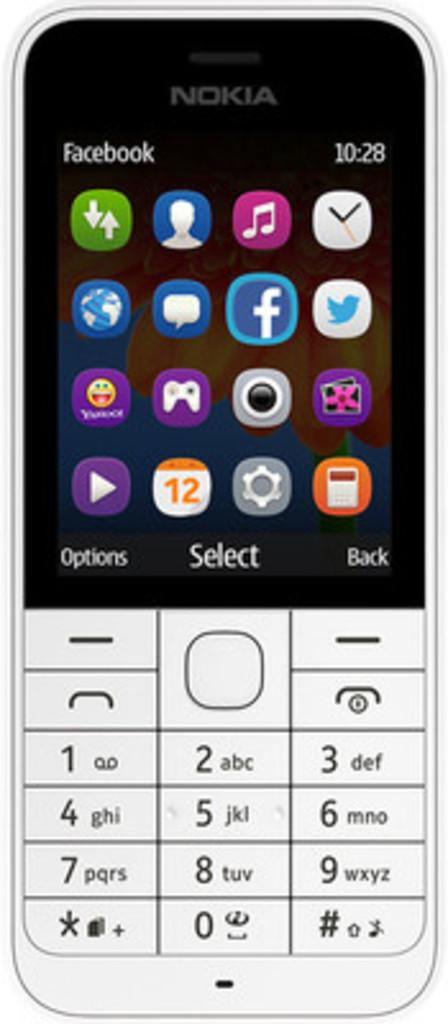<image>
Create a compact narrative representing the image presented. The Nokia phone image has Facebook at the top of the screen. 